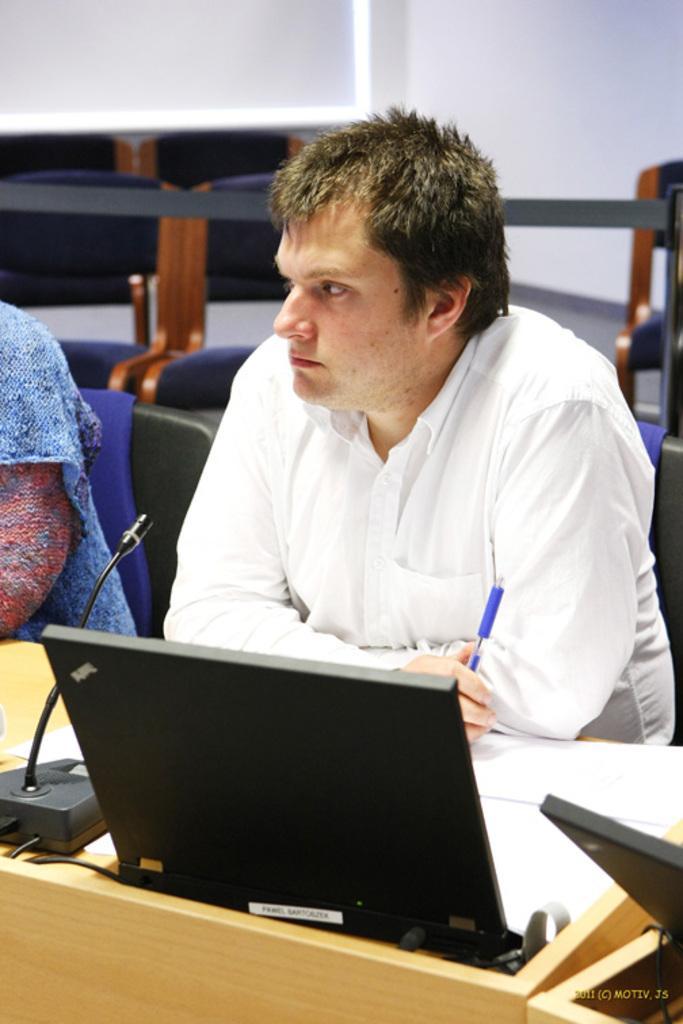Describe this image in one or two sentences. There is a man sitting at desk wearing white color shirt holding pen there is a micro phone and laptop placed on desk. 